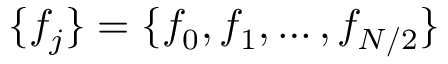<formula> <loc_0><loc_0><loc_500><loc_500>\{ f _ { j } \} = \{ f _ { 0 } , f _ { 1 } , \dots , f _ { N / 2 } \}</formula> 